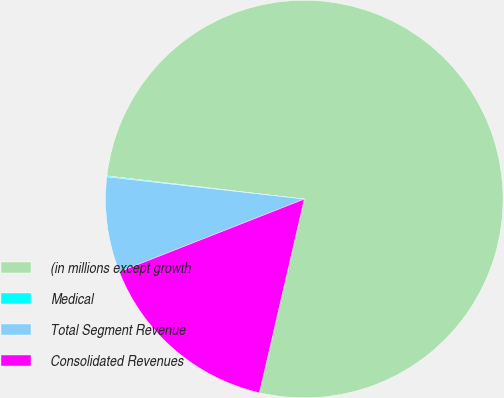Convert chart to OTSL. <chart><loc_0><loc_0><loc_500><loc_500><pie_chart><fcel>(in millions except growth<fcel>Medical<fcel>Total Segment Revenue<fcel>Consolidated Revenues<nl><fcel>76.76%<fcel>0.08%<fcel>7.75%<fcel>15.41%<nl></chart> 